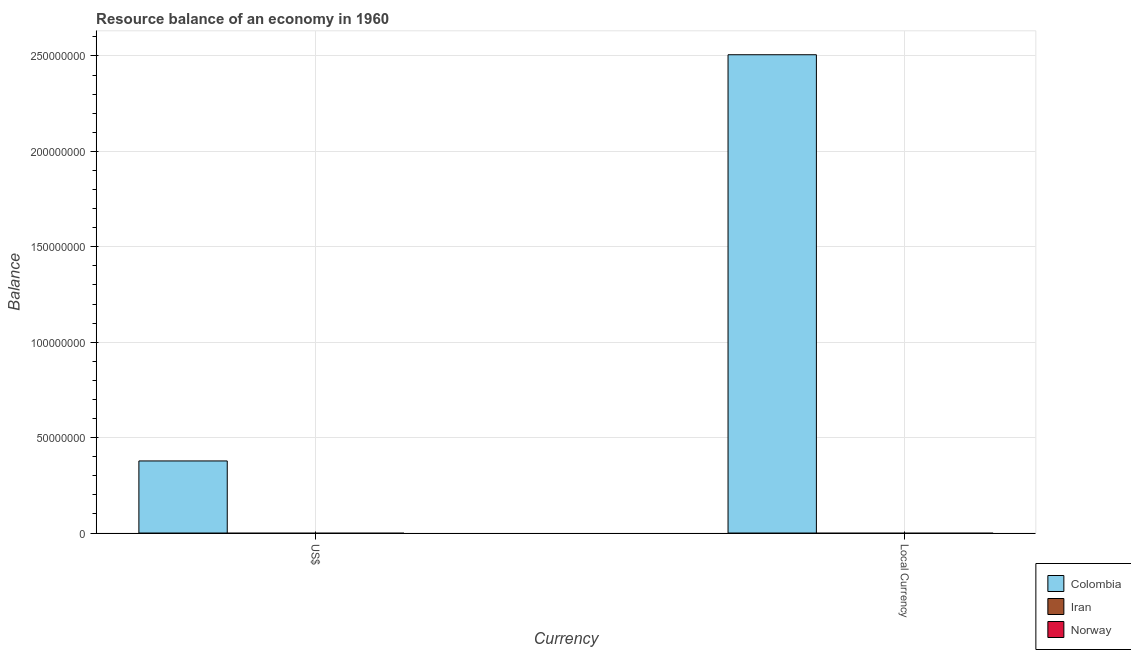How many bars are there on the 2nd tick from the left?
Keep it short and to the point. 1. What is the label of the 1st group of bars from the left?
Provide a succinct answer. US$. What is the resource balance in us$ in Iran?
Your answer should be very brief. 0. Across all countries, what is the maximum resource balance in constant us$?
Offer a terse response. 2.51e+08. What is the total resource balance in us$ in the graph?
Offer a very short reply. 3.78e+07. What is the difference between the resource balance in constant us$ in Colombia and the resource balance in us$ in Iran?
Your answer should be very brief. 2.51e+08. What is the average resource balance in constant us$ per country?
Provide a short and direct response. 8.36e+07. In how many countries, is the resource balance in us$ greater than 120000000 units?
Your answer should be compact. 0. In how many countries, is the resource balance in us$ greater than the average resource balance in us$ taken over all countries?
Your answer should be very brief. 1. Does the graph contain any zero values?
Provide a short and direct response. Yes. Does the graph contain grids?
Make the answer very short. Yes. Where does the legend appear in the graph?
Provide a succinct answer. Bottom right. How many legend labels are there?
Your answer should be very brief. 3. How are the legend labels stacked?
Provide a succinct answer. Vertical. What is the title of the graph?
Give a very brief answer. Resource balance of an economy in 1960. Does "Saudi Arabia" appear as one of the legend labels in the graph?
Keep it short and to the point. No. What is the label or title of the X-axis?
Ensure brevity in your answer.  Currency. What is the label or title of the Y-axis?
Offer a very short reply. Balance. What is the Balance of Colombia in US$?
Offer a very short reply. 3.78e+07. What is the Balance of Colombia in Local Currency?
Your answer should be compact. 2.51e+08. What is the Balance of Iran in Local Currency?
Your answer should be very brief. 0. What is the Balance in Norway in Local Currency?
Ensure brevity in your answer.  0. Across all Currency, what is the maximum Balance in Colombia?
Make the answer very short. 2.51e+08. Across all Currency, what is the minimum Balance in Colombia?
Keep it short and to the point. 3.78e+07. What is the total Balance in Colombia in the graph?
Ensure brevity in your answer.  2.88e+08. What is the total Balance of Iran in the graph?
Your answer should be very brief. 0. What is the total Balance of Norway in the graph?
Provide a succinct answer. 0. What is the difference between the Balance in Colombia in US$ and that in Local Currency?
Offer a terse response. -2.13e+08. What is the average Balance in Colombia per Currency?
Offer a terse response. 1.44e+08. What is the ratio of the Balance of Colombia in US$ to that in Local Currency?
Make the answer very short. 0.15. What is the difference between the highest and the second highest Balance in Colombia?
Offer a terse response. 2.13e+08. What is the difference between the highest and the lowest Balance in Colombia?
Your answer should be compact. 2.13e+08. 